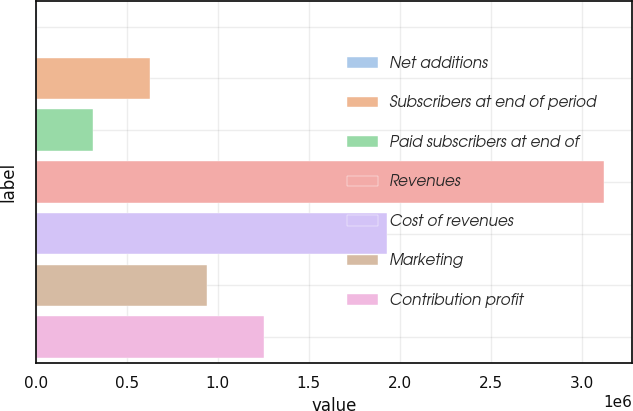<chart> <loc_0><loc_0><loc_500><loc_500><bar_chart><fcel>Net additions<fcel>Subscribers at end of period<fcel>Paid subscribers at end of<fcel>Revenues<fcel>Cost of revenues<fcel>Marketing<fcel>Contribution profit<nl><fcel>4894<fcel>628261<fcel>316577<fcel>3.12173e+06<fcel>1.93242e+06<fcel>939944<fcel>1.25163e+06<nl></chart> 